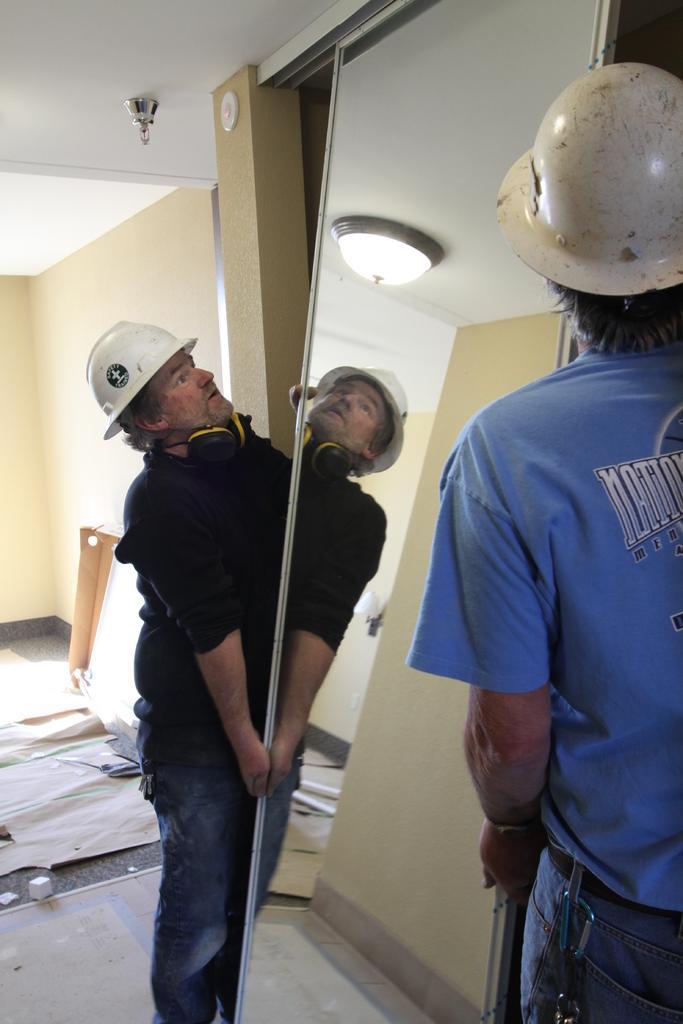Could you give a brief overview of what you see in this image? In this image we can see two persons wearing helmets are holding a mirror in their hands. One person wearing a black dress and a headphone. In the background, we can see some lights and papers placed on the ground. 